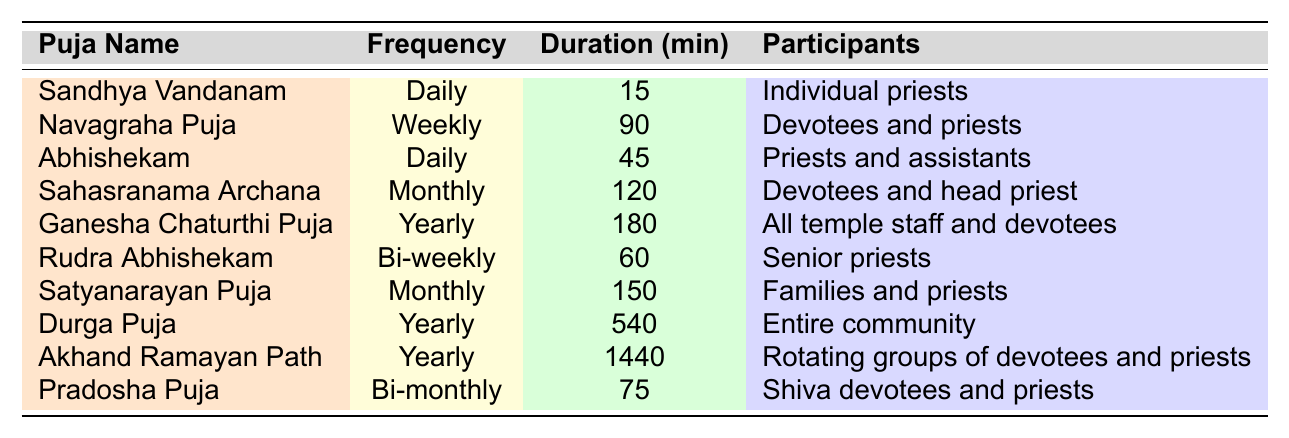What is the duration of the Sandhya Vandanam puja? The table directly states the duration for Sandhya Vandanam as 15 minutes.
Answer: 15 minutes How often is the Navagraha Puja performed? According to the table, Navagraha Puja is performed weekly.
Answer: Weekly What is the total duration of the monthly pujas? The Sahasranama Archana (120 minutes) and Satyanarayan Puja (150 minutes) are the monthly pujas, so their total duration is 120 + 150 = 270 minutes.
Answer: 270 minutes Which puja has the longest duration? The Akhand Ramayan Path has the longest duration of 1440 minutes as per the data.
Answer: Akhand Ramayan Path Are there any daily pujas that require more than 30 minutes? Yes, the Abhishekam, which takes 45 minutes, qualifies as a daily puja exceeding 30 minutes.
Answer: Yes What is the frequency of the Rudra Abhishekam? The table shows that the frequency of Rudra Abhishekam is bi-weekly.
Answer: Bi-weekly How many participants are involved in the Durga Puja? The Durga Puja involves the entire community as mentioned in the table.
Answer: Entire community Calculate the average duration of all pujas performed in the temple. The total duration of all pujas is: 15 + 90 + 45 + 120 + 180 + 60 + 150 + 540 + 1440 + 75 = 2495 minutes. There are 10 pujas, so the average duration is 2495 / 10 = 249.5 minutes.
Answer: 249.5 minutes Which puja has a duration of 150 minutes? The table indicates that the Satyanarayan Puja has a duration of 150 minutes.
Answer: Satyanarayan Puja Is the Akhand Ramayan Path performed more frequently than the Ganesha Chaturthi Puja? Yes, Akhand Ramayan Path occurs yearly, the same as Ganesha Chaturthi Puja; thus, they occur with the same frequency.
Answer: No What is the difference in duration between the longest and shortest puja? The longest puja is Akhand Ramayan Path at 1440 minutes and the shortest is Sandhya Vandanam at 15 minutes. The difference is 1440 - 15 = 1425 minutes.
Answer: 1425 minutes 